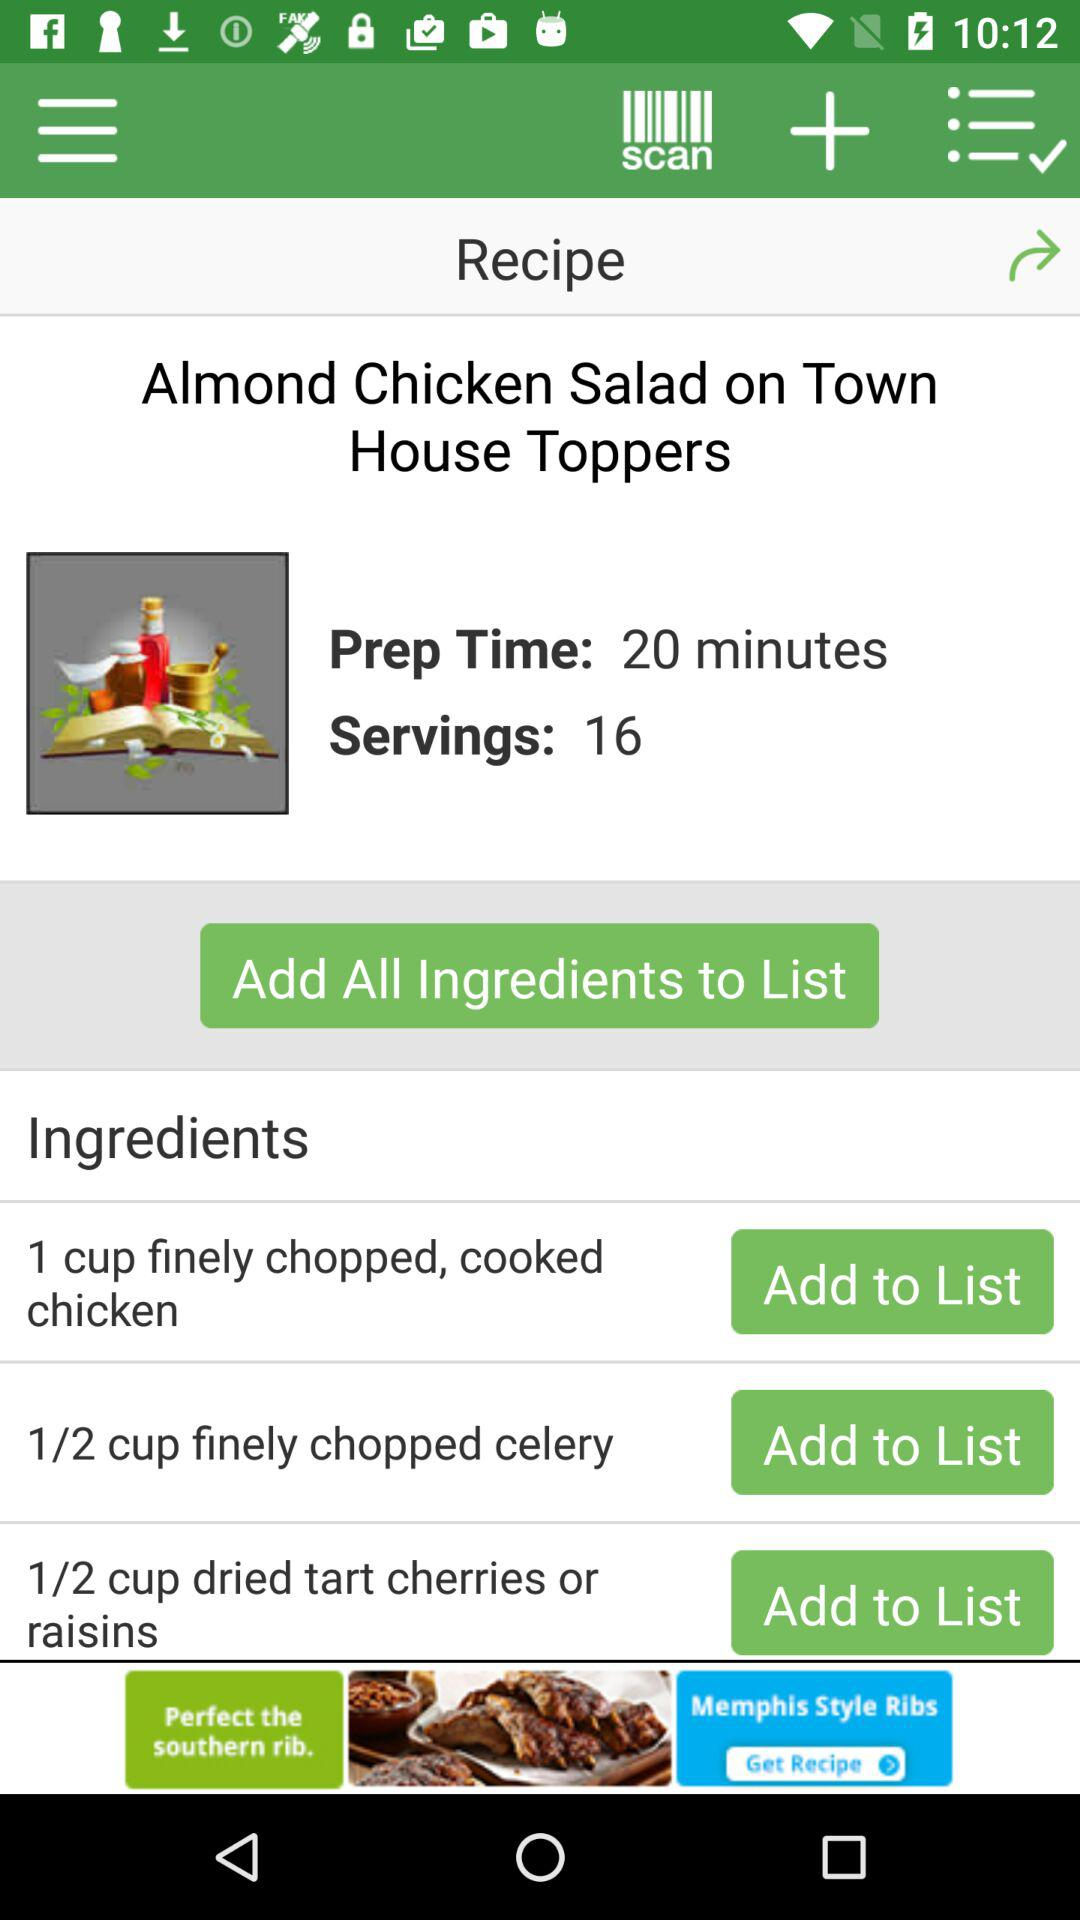What is the dish name? The dish name is "Almond Chicken Salad on Town House Toppers". 